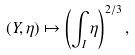Convert formula to latex. <formula><loc_0><loc_0><loc_500><loc_500>( Y , \eta ) \mapsto \left ( \int _ { I } \eta \right ) ^ { 2 / 3 } ,</formula> 